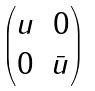<formula> <loc_0><loc_0><loc_500><loc_500>\begin{pmatrix} u & 0 \\ 0 & \bar { u } \end{pmatrix}</formula> 